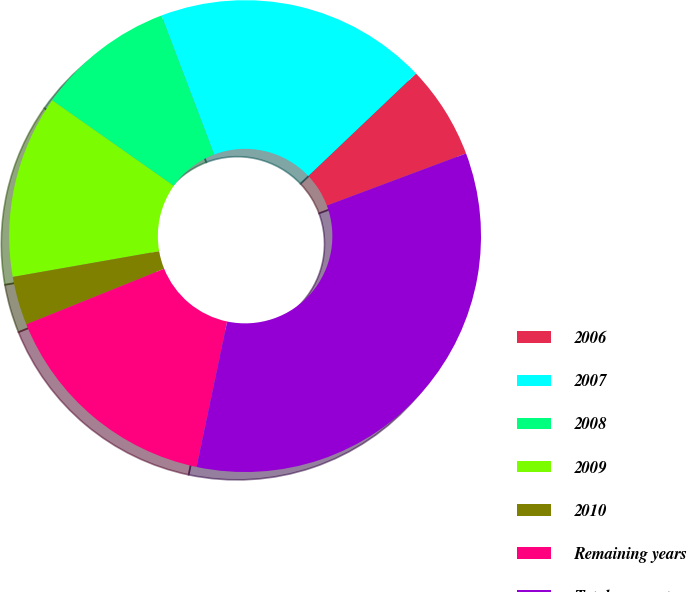Convert chart. <chart><loc_0><loc_0><loc_500><loc_500><pie_chart><fcel>2006<fcel>2007<fcel>2008<fcel>2009<fcel>2010<fcel>Remaining years<fcel>Total payments<nl><fcel>6.4%<fcel>18.67%<fcel>9.47%<fcel>12.53%<fcel>3.33%<fcel>15.6%<fcel>34.0%<nl></chart> 